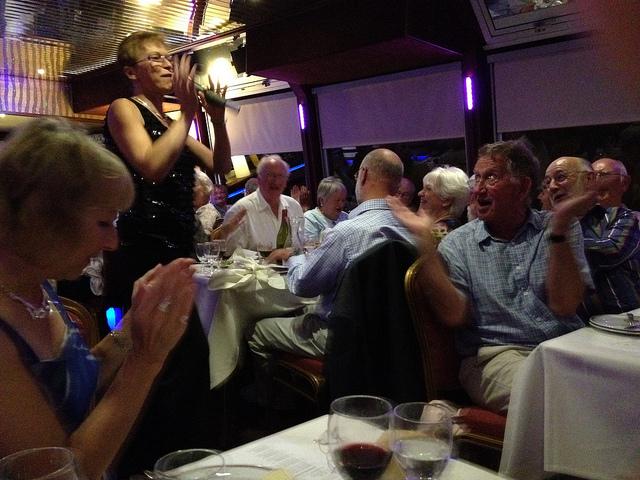Is this a formal event?
Give a very brief answer. Yes. What is draped over the back of the man's chair?
Quick response, please. Jacket. What age group are these people in?
Write a very short answer. Seniors. What is she holding?
Short answer required. Microphone. 